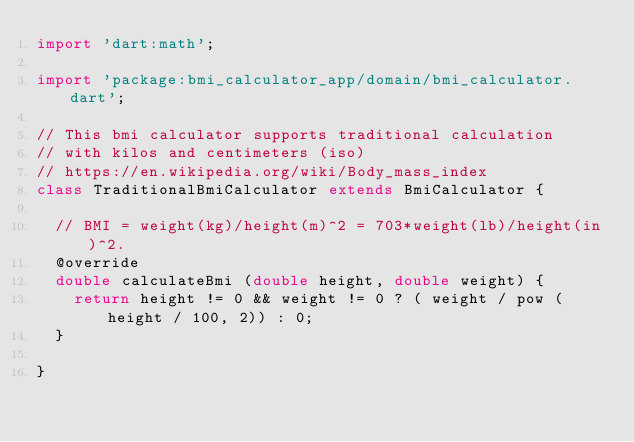<code> <loc_0><loc_0><loc_500><loc_500><_Dart_>import 'dart:math';

import 'package:bmi_calculator_app/domain/bmi_calculator.dart';

// This bmi calculator supports traditional calculation
// with kilos and centimeters (iso)
// https://en.wikipedia.org/wiki/Body_mass_index
class TraditionalBmiCalculator extends BmiCalculator {

  // BMI = weight(kg)/height(m)^2 = 703*weight(lb)/height(in)^2.
  @override
  double calculateBmi (double height, double weight) {
    return height != 0 && weight != 0 ? ( weight / pow (height / 100, 2)) : 0;
  }

}
</code> 